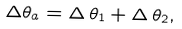<formula> <loc_0><loc_0><loc_500><loc_500>\Delta \theta _ { a } = \Delta \, \theta _ { 1 } + \Delta \, \theta _ { 2 } ,</formula> 